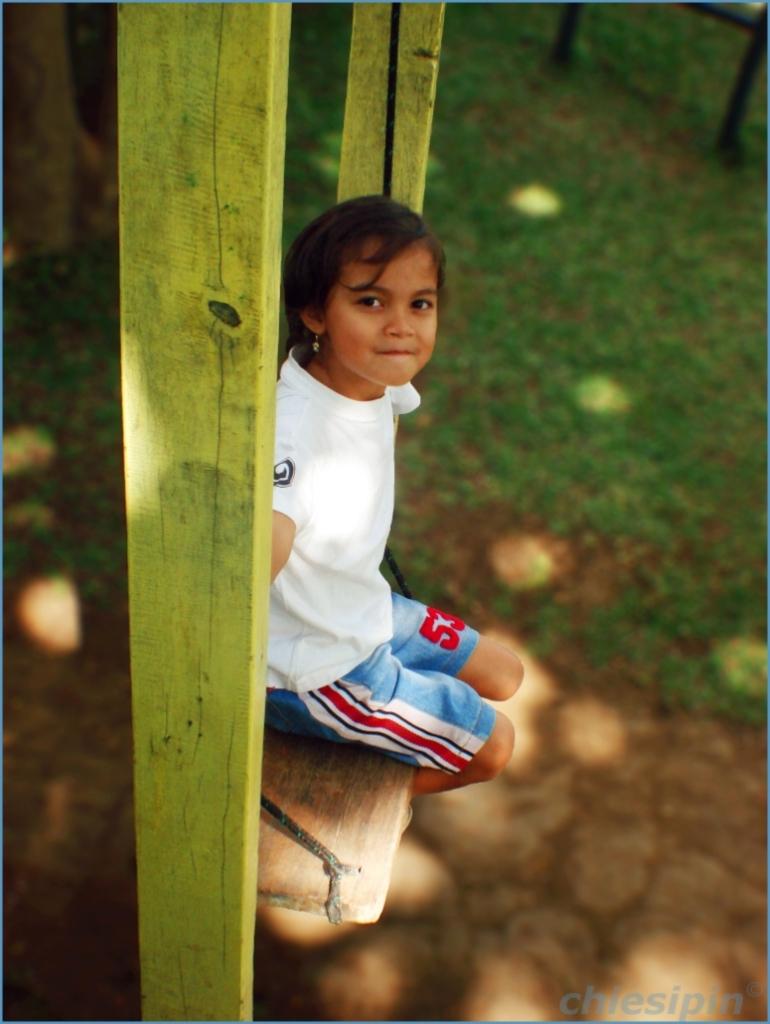What number is on her pants?
Give a very brief answer. 53. 